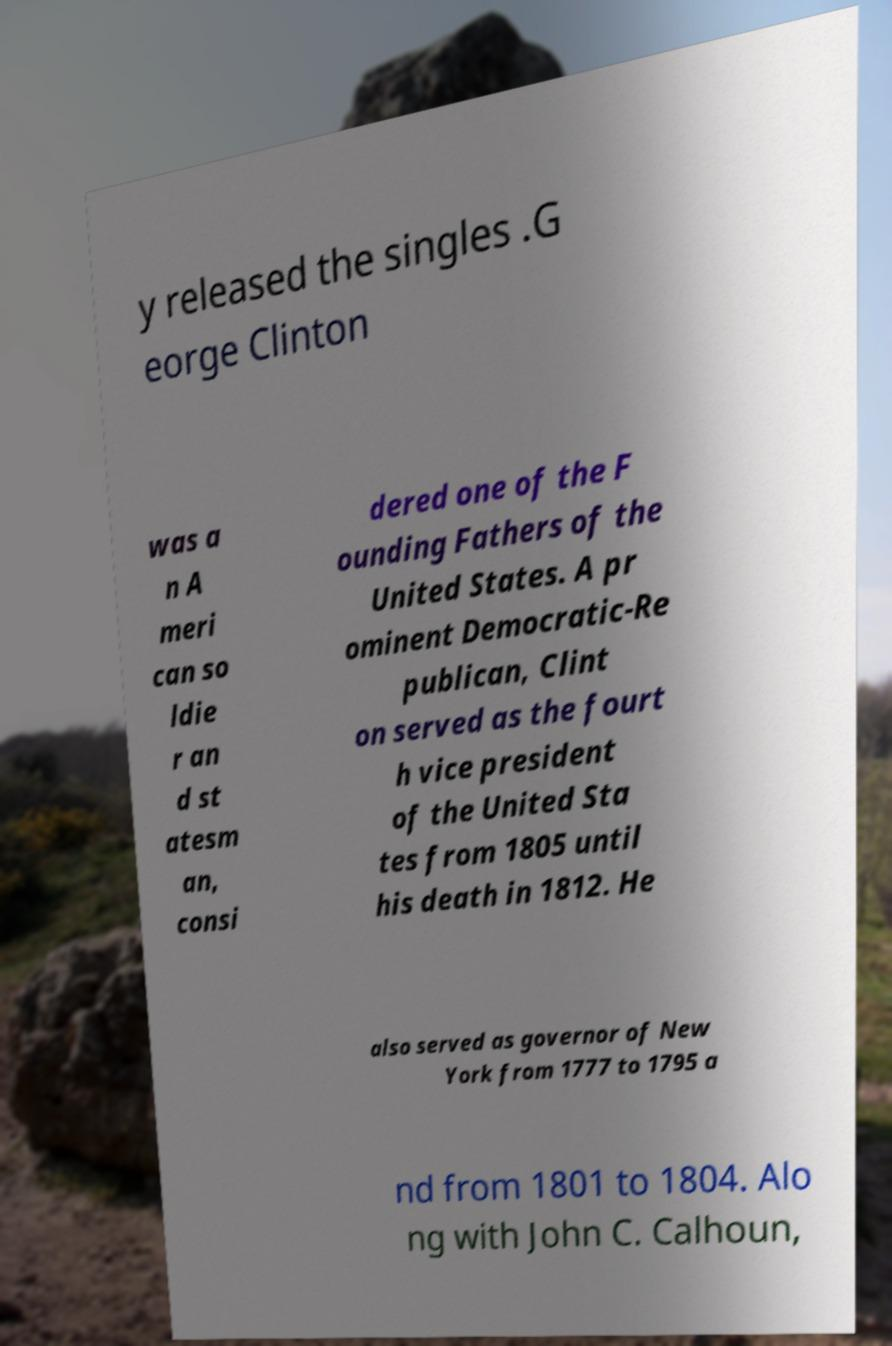Please identify and transcribe the text found in this image. y released the singles .G eorge Clinton was a n A meri can so ldie r an d st atesm an, consi dered one of the F ounding Fathers of the United States. A pr ominent Democratic-Re publican, Clint on served as the fourt h vice president of the United Sta tes from 1805 until his death in 1812. He also served as governor of New York from 1777 to 1795 a nd from 1801 to 1804. Alo ng with John C. Calhoun, 